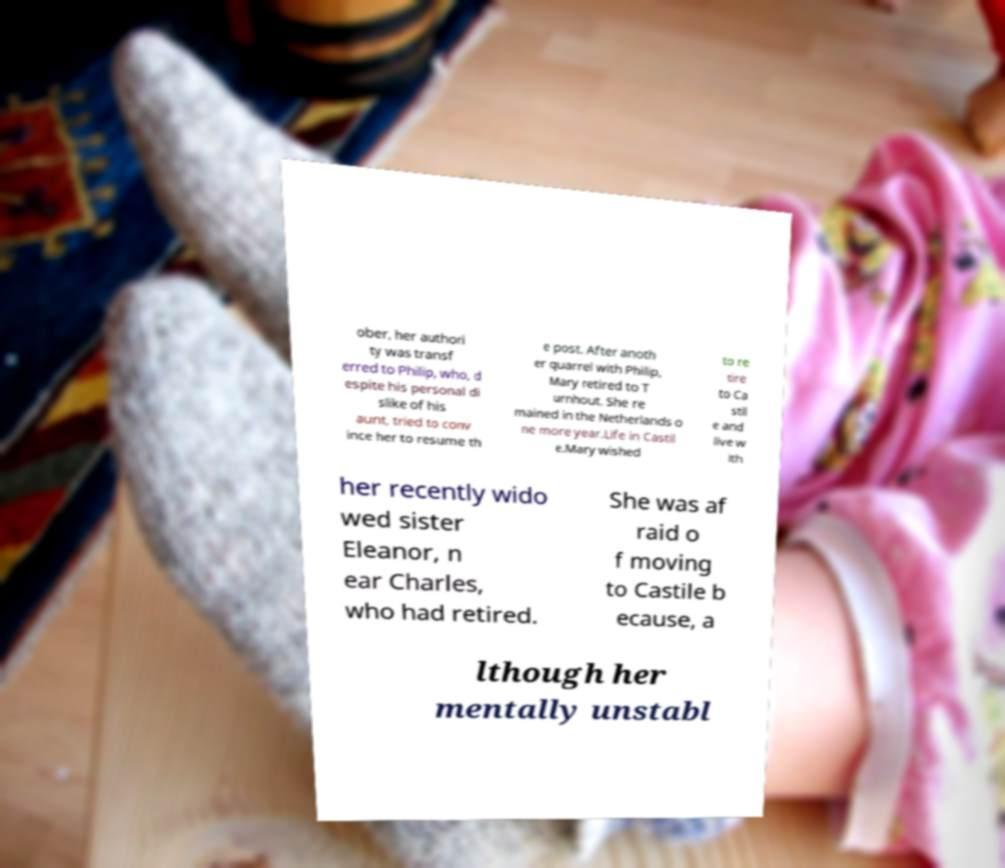Can you read and provide the text displayed in the image?This photo seems to have some interesting text. Can you extract and type it out for me? ober, her authori ty was transf erred to Philip, who, d espite his personal di slike of his aunt, tried to conv ince her to resume th e post. After anoth er quarrel with Philip, Mary retired to T urnhout. She re mained in the Netherlands o ne more year.Life in Castil e.Mary wished to re tire to Ca stil e and live w ith her recently wido wed sister Eleanor, n ear Charles, who had retired. She was af raid o f moving to Castile b ecause, a lthough her mentally unstabl 